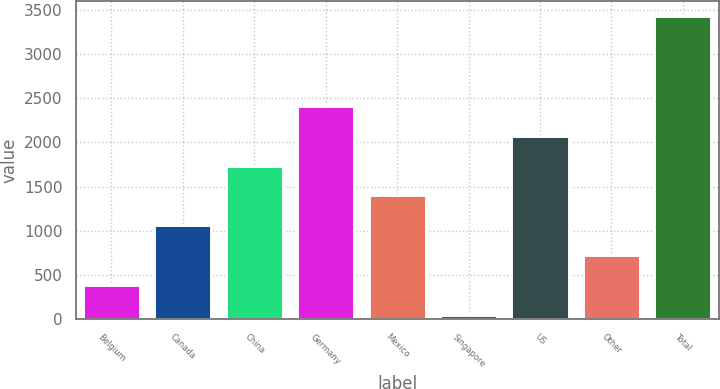<chart> <loc_0><loc_0><loc_500><loc_500><bar_chart><fcel>Belgium<fcel>Canada<fcel>China<fcel>Germany<fcel>Mexico<fcel>Singapore<fcel>US<fcel>Other<fcel>Total<nl><fcel>390.2<fcel>1064.6<fcel>1739<fcel>2413.4<fcel>1401.8<fcel>53<fcel>2076.2<fcel>727.4<fcel>3425<nl></chart> 